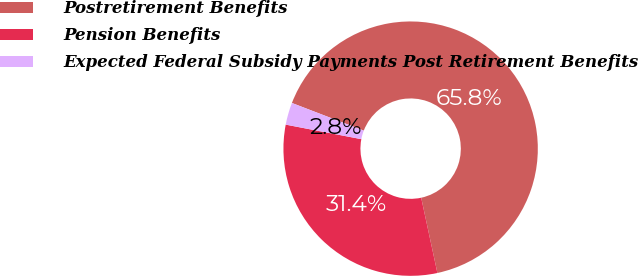Convert chart to OTSL. <chart><loc_0><loc_0><loc_500><loc_500><pie_chart><fcel>Postretirement Benefits<fcel>Pension Benefits<fcel>Expected Federal Subsidy Payments Post Retirement Benefits<nl><fcel>65.78%<fcel>31.4%<fcel>2.82%<nl></chart> 